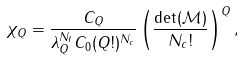<formula> <loc_0><loc_0><loc_500><loc_500>\chi _ { Q } = \frac { C _ { Q } } { \lambda _ { Q } ^ { N _ { f } } C _ { 0 } ( Q ! ) ^ { N _ { c } } } \left ( \frac { \det ( \mathcal { M } ) } { N _ { c } ! } \right ) ^ { Q } ,</formula> 